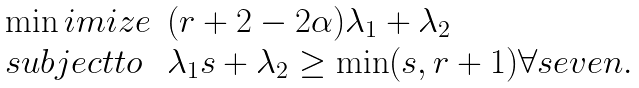Convert formula to latex. <formula><loc_0><loc_0><loc_500><loc_500>\begin{array} { l l } \min i m i z e & ( r + 2 - 2 \alpha ) \lambda _ { 1 } + \lambda _ { 2 } \\ s u b j e c t t o & \lambda _ { 1 } s + \lambda _ { 2 } \geq \min ( s , r + 1 ) \forall s e v e n . \end{array}</formula> 